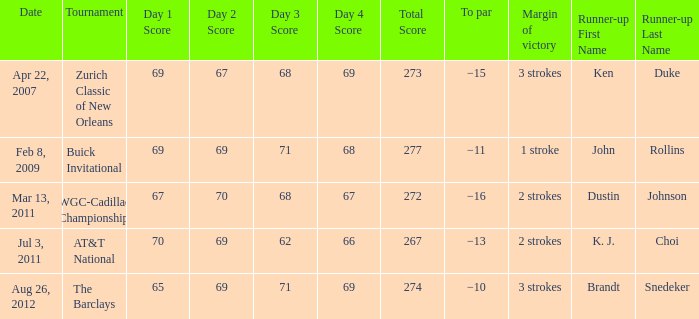Who came in second in the contest that had a victory difference of 2 strokes and a to par of −16? Dustin Johnson. 